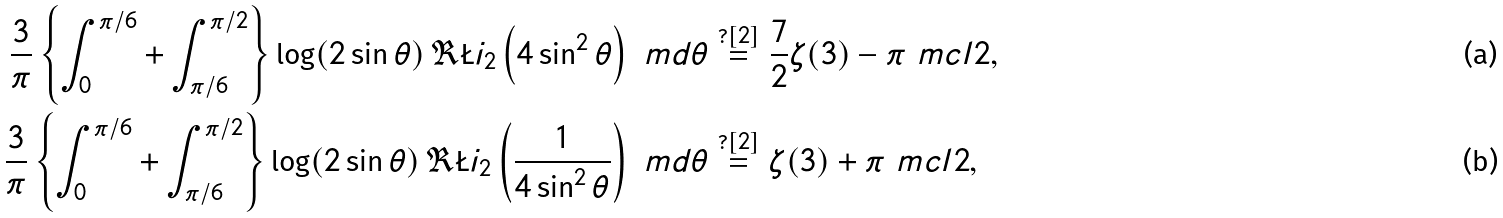<formula> <loc_0><loc_0><loc_500><loc_500>\frac { 3 } { \pi } \left \{ \int _ { 0 } ^ { \pi / 6 } + \int _ { \pi / 6 } ^ { \pi / 2 } \right \} \log ( 2 \sin \theta ) \, \Re \L i _ { 2 } \left ( 4 \sin ^ { 2 } \theta \right ) \ m d \theta & \stackrel { ? [ 2 ] } { = } \frac { 7 } { 2 } \zeta ( 3 ) - \pi \ m c l { 2 } , \\ \frac { 3 } { \pi } \left \{ \int _ { 0 } ^ { \pi / 6 } + \int _ { \pi / 6 } ^ { \pi / 2 } \right \} \log ( 2 \sin \theta ) \, \Re \L i _ { 2 } \left ( \frac { 1 } { 4 \sin ^ { 2 } \theta } \right ) \ m d \theta & \stackrel { ? [ 2 ] } { = } \zeta ( 3 ) + \pi \ m c l { 2 } ,</formula> 